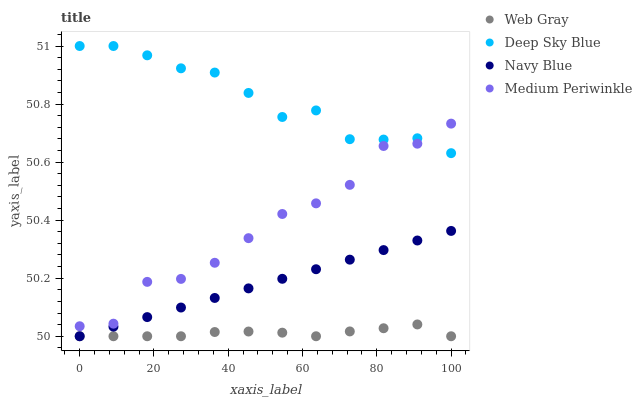Does Web Gray have the minimum area under the curve?
Answer yes or no. Yes. Does Deep Sky Blue have the maximum area under the curve?
Answer yes or no. Yes. Does Medium Periwinkle have the minimum area under the curve?
Answer yes or no. No. Does Medium Periwinkle have the maximum area under the curve?
Answer yes or no. No. Is Navy Blue the smoothest?
Answer yes or no. Yes. Is Medium Periwinkle the roughest?
Answer yes or no. Yes. Is Web Gray the smoothest?
Answer yes or no. No. Is Web Gray the roughest?
Answer yes or no. No. Does Navy Blue have the lowest value?
Answer yes or no. Yes. Does Medium Periwinkle have the lowest value?
Answer yes or no. No. Does Deep Sky Blue have the highest value?
Answer yes or no. Yes. Does Medium Periwinkle have the highest value?
Answer yes or no. No. Is Navy Blue less than Medium Periwinkle?
Answer yes or no. Yes. Is Deep Sky Blue greater than Web Gray?
Answer yes or no. Yes. Does Web Gray intersect Navy Blue?
Answer yes or no. Yes. Is Web Gray less than Navy Blue?
Answer yes or no. No. Is Web Gray greater than Navy Blue?
Answer yes or no. No. Does Navy Blue intersect Medium Periwinkle?
Answer yes or no. No. 